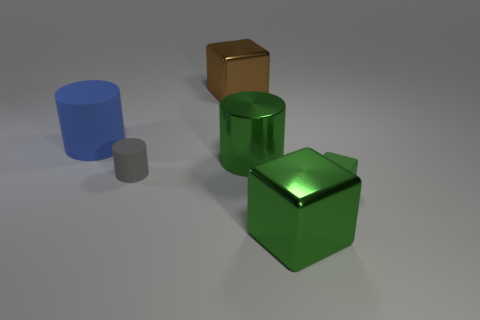Do the large rubber thing and the rubber block have the same color?
Your answer should be compact. No. Is there any other thing that is the same shape as the gray thing?
Provide a succinct answer. Yes. Are there fewer purple objects than big cylinders?
Ensure brevity in your answer.  Yes. There is a thing that is to the right of the big green object in front of the small gray rubber object; what is its color?
Your answer should be compact. Green. What material is the large green thing behind the tiny thing right of the green object in front of the green rubber thing made of?
Keep it short and to the point. Metal. There is a cylinder right of the brown metal block; does it have the same size as the blue object?
Your answer should be compact. Yes. What material is the block behind the green shiny cylinder?
Make the answer very short. Metal. Are there more big metallic cylinders than large red shiny things?
Your answer should be very brief. Yes. How many things are either green objects to the left of the small rubber block or metallic things?
Keep it short and to the point. 3. What number of blue cylinders are on the right side of the matte thing that is on the right side of the tiny gray rubber object?
Give a very brief answer. 0. 